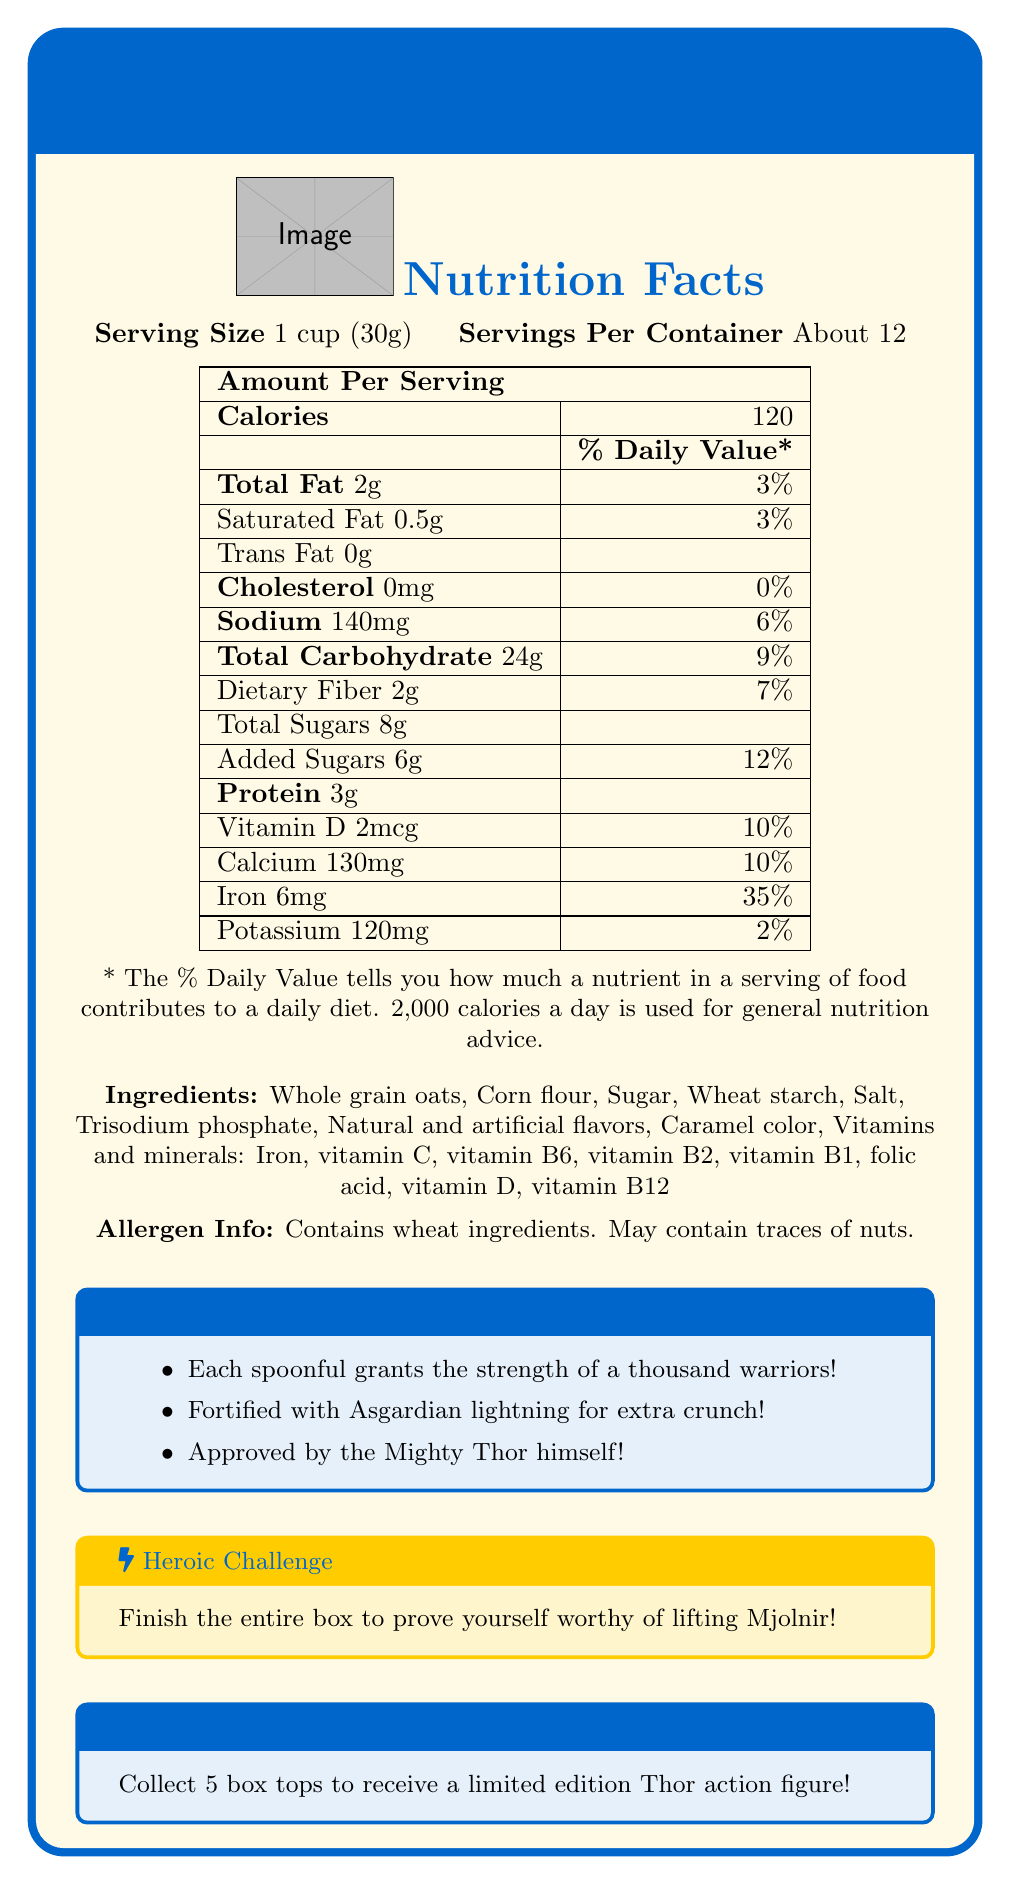what is the serving size for Thor's Mighty Thunder Crunch Cereal? The document lists the serving size as "1 cup (30g)".
Answer: 1 cup (30g) how many calories are in one serving? The document lists the calorie content for one serving as 120.
Answer: 120 calories what percentage of the daily value is the total fat in one serving? The document shows the total fat daily value percentage as 3%.
Answer: 3% how many grams of total sugars are in one serving? The document indicates that there are 8 grams of total sugars in one serving.
Answer: 8g which ingredient is listed first in Thor's Mighty Thunder Crunch Cereal? The document lists "Whole grain oats" as the first ingredient.
Answer: Whole grain oats how many servings are in one container? The document states that there are "About 12" servings per container.
Answer: About 12 what vitamin has the highest daily value percentage in one serving? The document shows iron with a daily value percentage of 35%, the highest among the listed vitamins and minerals.
Answer: Iron how much protein is in one serving? The document lists the protein content for one serving as 3 grams.
Answer: 3g which of these is not one of the fun facts mentioned in the document? A. Grants wisdom of Odin’s ravens B. Fortified with Asgardian lightning for extra crunch C. Approved by the Mighty Thor himself The fun facts provided in the document do not mention anything about Odin’s ravens. They mention strength of a thousand warriors, Asgardian lightning, and approval by Thor.
Answer: A what must you do to prove yourself worthy of lifting Mjolnir? A. Finish a marathon B. Finish the entire box C. Solve a riddle The document states that finishing the entire box of cereal will prove yourself worthy of lifting Mjolnir.
Answer: B is there any trans fat in this cereal? The document lists the trans fat content as 0g, meaning there is no trans fat in the cereal.
Answer: No does this cereal contain any nuts? The document mentions that the cereal may contain traces of nuts, but it doesn't definitively state whether it does or not.
Answer: Cannot be determined what should you do to receive a limited edition Thor action figure? The document specifies that you need to collect 5 box tops to receive a limited edition Thor action figure.
Answer: Collect 5 box tops is Thor's Mighty Thunder Crunch Cereal approved by Thor? One of the fun facts in the document states that the cereal is approved by the Mighty Thor himself.
Answer: Yes summarize the main idea of the document. The document provides details about the product "Thor's Mighty Thunder Crunch Cereal," including its nutritional content, ingredients, allergen information, and promotions tied to the product, along with the fun fact that it is endorsed by Thor.
Answer: Thor's Mighty Thunder Crunch Cereal is a fortified cereal endorsed by Thor, providing various nutrients and fun facts. It has a serving size of 1 cup (30g) and contains about 12 servings per container. The document includes nutritional information, ingredients, allergen info, fun facts, a heroic challenge, and a special offer for a Thor action figure. 